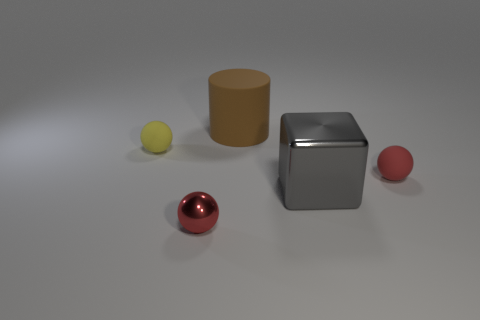Add 1 rubber spheres. How many objects exist? 6 Subtract all balls. How many objects are left? 2 Subtract 0 blue cubes. How many objects are left? 5 Subtract all tiny yellow rubber balls. Subtract all tiny yellow spheres. How many objects are left? 3 Add 3 metal balls. How many metal balls are left? 4 Add 3 spheres. How many spheres exist? 6 